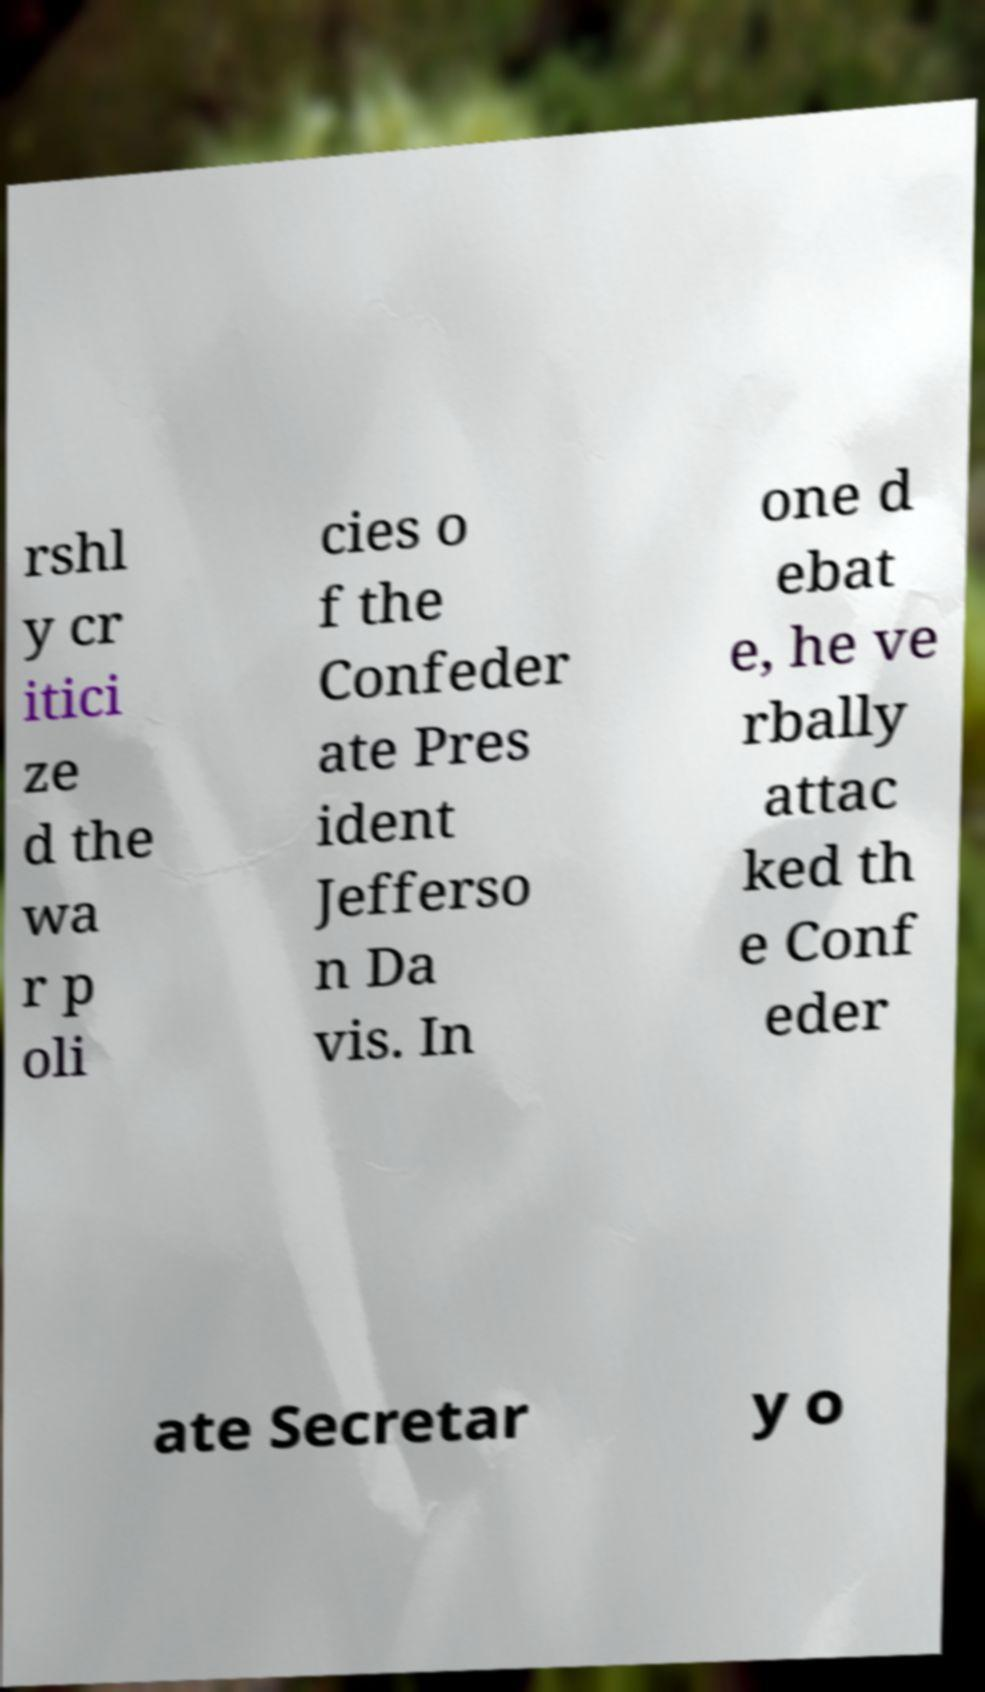Could you assist in decoding the text presented in this image and type it out clearly? rshl y cr itici ze d the wa r p oli cies o f the Confeder ate Pres ident Jefferso n Da vis. In one d ebat e, he ve rbally attac ked th e Conf eder ate Secretar y o 